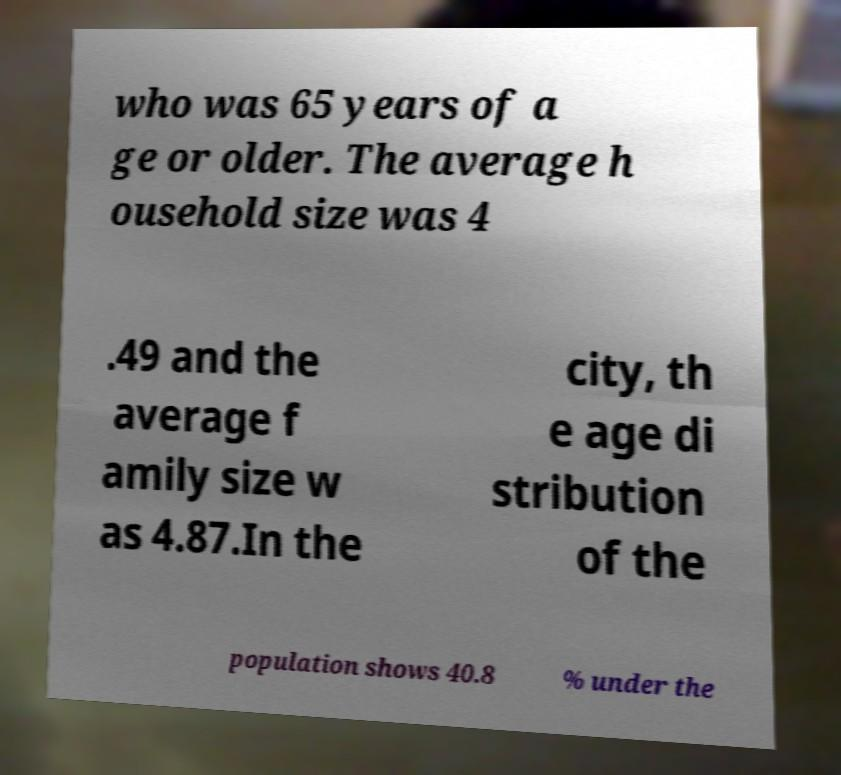What messages or text are displayed in this image? I need them in a readable, typed format. who was 65 years of a ge or older. The average h ousehold size was 4 .49 and the average f amily size w as 4.87.In the city, th e age di stribution of the population shows 40.8 % under the 